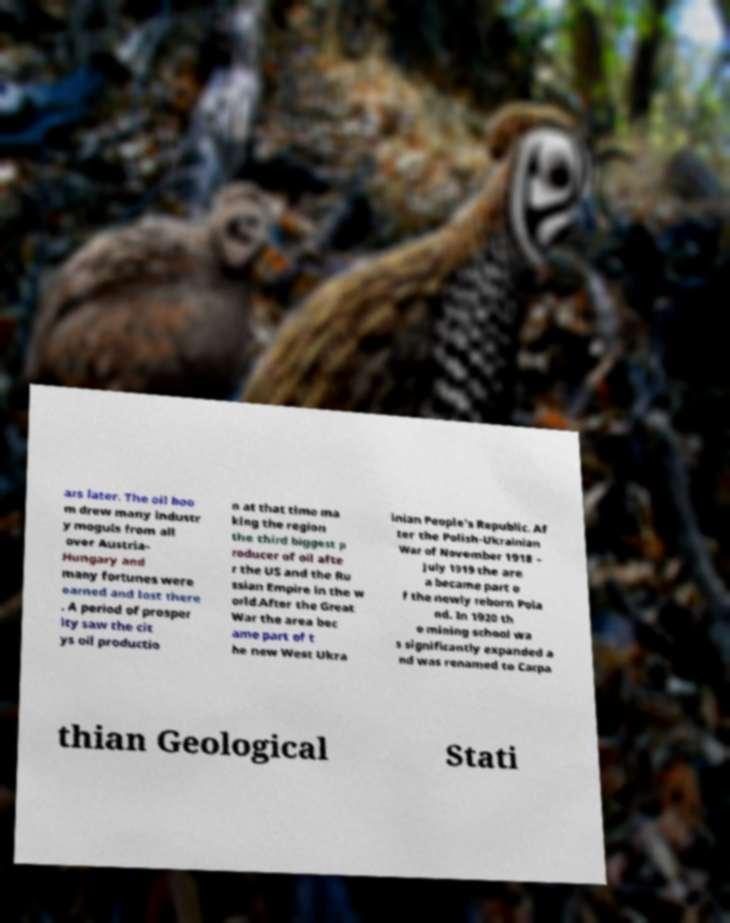For documentation purposes, I need the text within this image transcribed. Could you provide that? ars later. The oil boo m drew many industr y moguls from all over Austria- Hungary and many fortunes were earned and lost there . A period of prosper ity saw the cit ys oil productio n at that time ma king the region the third biggest p roducer of oil afte r the US and the Ru ssian Empire in the w orld.After the Great War the area bec ame part of t he new West Ukra inian People's Republic. Af ter the Polish-Ukrainian War of November 1918 – July 1919 the are a became part o f the newly reborn Pola nd. In 1920 th e mining school wa s significantly expanded a nd was renamed to Carpa thian Geological Stati 